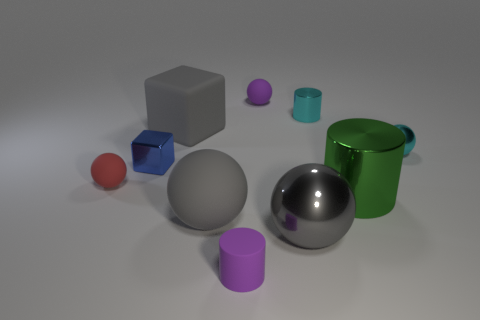Subtract all purple balls. How many balls are left? 4 Subtract all tiny metallic balls. How many balls are left? 4 Subtract all yellow balls. Subtract all brown cylinders. How many balls are left? 5 Subtract all cylinders. How many objects are left? 7 Add 9 large green cylinders. How many large green cylinders exist? 10 Subtract 0 gray cylinders. How many objects are left? 10 Subtract all tiny brown objects. Subtract all small matte cylinders. How many objects are left? 9 Add 5 cyan metallic cylinders. How many cyan metallic cylinders are left? 6 